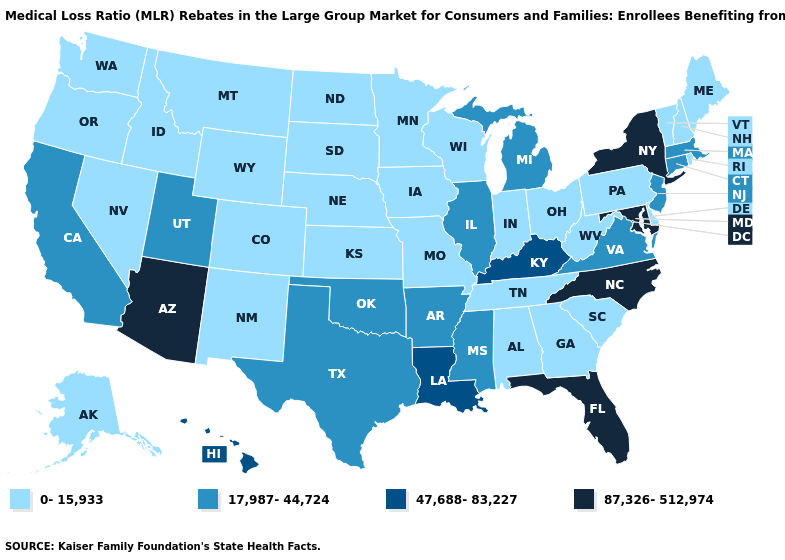Name the states that have a value in the range 87,326-512,974?
Concise answer only. Arizona, Florida, Maryland, New York, North Carolina. Does New York have the lowest value in the Northeast?
Keep it brief. No. What is the value of New Hampshire?
Quick response, please. 0-15,933. Name the states that have a value in the range 87,326-512,974?
Be succinct. Arizona, Florida, Maryland, New York, North Carolina. Name the states that have a value in the range 0-15,933?
Answer briefly. Alabama, Alaska, Colorado, Delaware, Georgia, Idaho, Indiana, Iowa, Kansas, Maine, Minnesota, Missouri, Montana, Nebraska, Nevada, New Hampshire, New Mexico, North Dakota, Ohio, Oregon, Pennsylvania, Rhode Island, South Carolina, South Dakota, Tennessee, Vermont, Washington, West Virginia, Wisconsin, Wyoming. Name the states that have a value in the range 47,688-83,227?
Answer briefly. Hawaii, Kentucky, Louisiana. What is the highest value in the Northeast ?
Answer briefly. 87,326-512,974. How many symbols are there in the legend?
Be succinct. 4. What is the lowest value in the USA?
Quick response, please. 0-15,933. Among the states that border Arizona , does California have the lowest value?
Short answer required. No. Does North Carolina have a higher value than North Dakota?
Write a very short answer. Yes. Does South Carolina have the lowest value in the South?
Write a very short answer. Yes. Does Alaska have the highest value in the USA?
Concise answer only. No. What is the value of Ohio?
Write a very short answer. 0-15,933. Name the states that have a value in the range 87,326-512,974?
Write a very short answer. Arizona, Florida, Maryland, New York, North Carolina. 